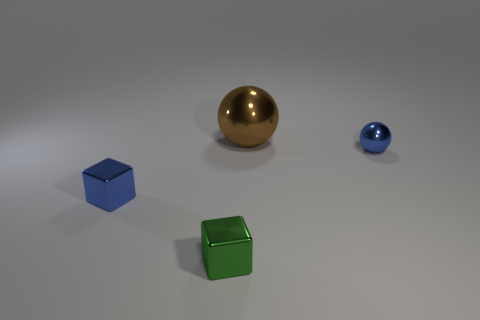Is there anything else that has the same size as the brown ball?
Provide a succinct answer. No. The metal object that is to the right of the brown metal object is what color?
Your answer should be very brief. Blue. Is the material of the small ball the same as the small green object?
Your response must be concise. Yes. How many things are either green metallic cubes or metallic objects in front of the large object?
Offer a very short reply. 3. There is a block that is the same color as the small shiny sphere; what is its size?
Provide a short and direct response. Small. There is a tiny shiny thing on the right side of the large brown sphere; what is its shape?
Your answer should be very brief. Sphere. There is a ball that is on the right side of the brown thing; is it the same color as the big metallic sphere?
Give a very brief answer. No. What material is the object that is the same color as the small metal ball?
Your answer should be very brief. Metal. There is a cube behind the green metallic thing; does it have the same size as the tiny green shiny thing?
Your response must be concise. Yes. Are there any small spheres of the same color as the large shiny ball?
Your response must be concise. No. 